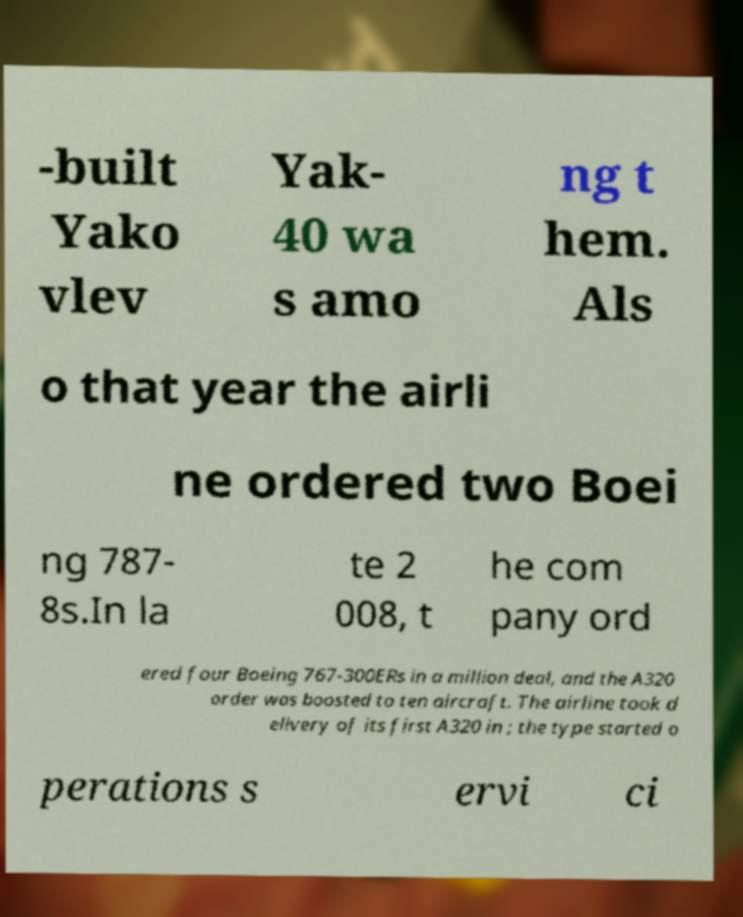For documentation purposes, I need the text within this image transcribed. Could you provide that? -built Yako vlev Yak- 40 wa s amo ng t hem. Als o that year the airli ne ordered two Boei ng 787- 8s.In la te 2 008, t he com pany ord ered four Boeing 767-300ERs in a million deal, and the A320 order was boosted to ten aircraft. The airline took d elivery of its first A320 in ; the type started o perations s ervi ci 